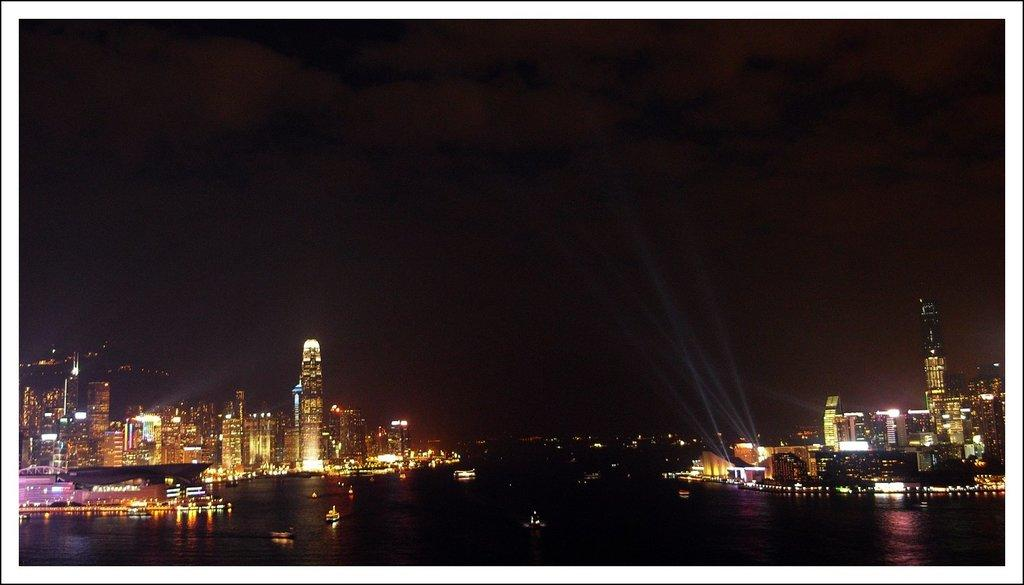What type of structures are visible in the image? There are multiple buildings in the image. What else can be seen on the water in the image? There are boats on the water in the image. Are there any additional features on the buildings? Yes, there are lights on the buildings. How would you describe the overall lighting in the image? The background of the image is dark. How much money is being exchanged between the head of the curve in the image? There is no curve, head, or money present in the image. 